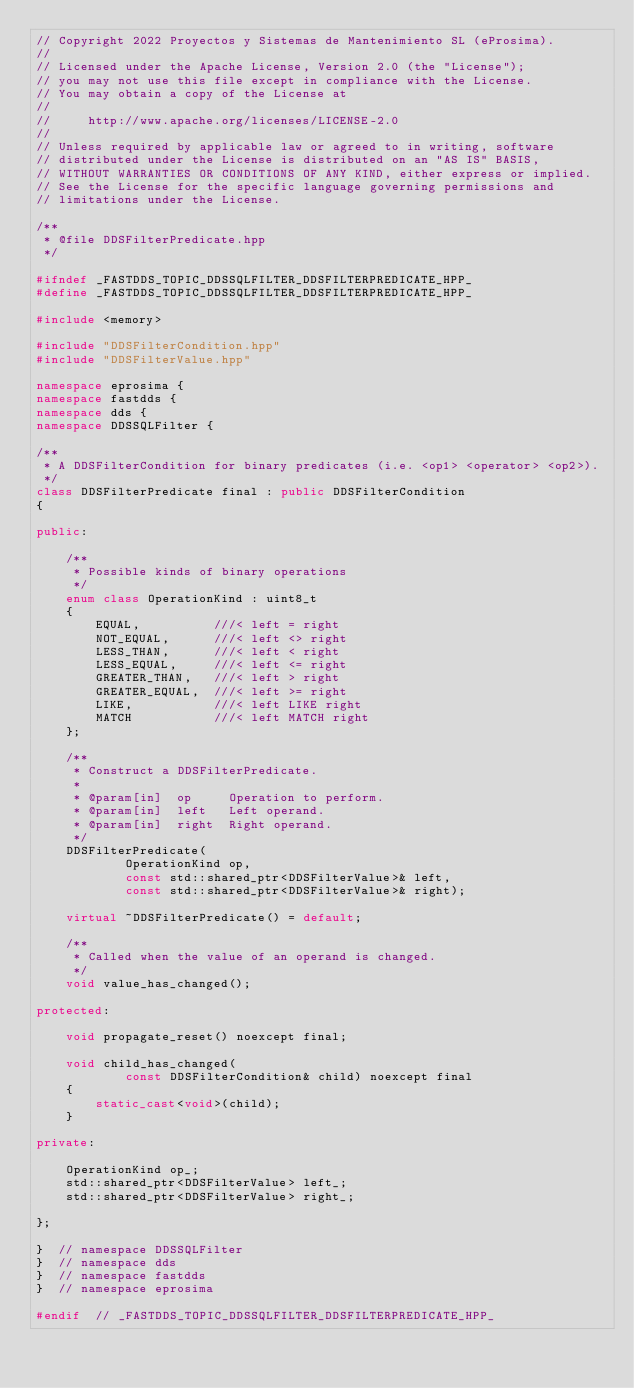Convert code to text. <code><loc_0><loc_0><loc_500><loc_500><_C++_>// Copyright 2022 Proyectos y Sistemas de Mantenimiento SL (eProsima).
//
// Licensed under the Apache License, Version 2.0 (the "License");
// you may not use this file except in compliance with the License.
// You may obtain a copy of the License at
//
//     http://www.apache.org/licenses/LICENSE-2.0
//
// Unless required by applicable law or agreed to in writing, software
// distributed under the License is distributed on an "AS IS" BASIS,
// WITHOUT WARRANTIES OR CONDITIONS OF ANY KIND, either express or implied.
// See the License for the specific language governing permissions and
// limitations under the License.

/**
 * @file DDSFilterPredicate.hpp
 */

#ifndef _FASTDDS_TOPIC_DDSSQLFILTER_DDSFILTERPREDICATE_HPP_
#define _FASTDDS_TOPIC_DDSSQLFILTER_DDSFILTERPREDICATE_HPP_

#include <memory>

#include "DDSFilterCondition.hpp"
#include "DDSFilterValue.hpp"

namespace eprosima {
namespace fastdds {
namespace dds {
namespace DDSSQLFilter {

/**
 * A DDSFilterCondition for binary predicates (i.e. <op1> <operator> <op2>).
 */
class DDSFilterPredicate final : public DDSFilterCondition
{

public:

    /**
     * Possible kinds of binary operations
     */
    enum class OperationKind : uint8_t
    {
        EQUAL,          ///< left = right
        NOT_EQUAL,      ///< left <> right
        LESS_THAN,      ///< left < right
        LESS_EQUAL,     ///< left <= right
        GREATER_THAN,   ///< left > right
        GREATER_EQUAL,  ///< left >= right
        LIKE,           ///< left LIKE right
        MATCH           ///< left MATCH right
    };

    /**
     * Construct a DDSFilterPredicate.
     *
     * @param[in]  op     Operation to perform.
     * @param[in]  left   Left operand.
     * @param[in]  right  Right operand.
     */
    DDSFilterPredicate(
            OperationKind op,
            const std::shared_ptr<DDSFilterValue>& left,
            const std::shared_ptr<DDSFilterValue>& right);

    virtual ~DDSFilterPredicate() = default;

    /**
     * Called when the value of an operand is changed.
     */
    void value_has_changed();

protected:

    void propagate_reset() noexcept final;

    void child_has_changed(
            const DDSFilterCondition& child) noexcept final
    {
        static_cast<void>(child);
    }

private:

    OperationKind op_;
    std::shared_ptr<DDSFilterValue> left_;
    std::shared_ptr<DDSFilterValue> right_;

};

}  // namespace DDSSQLFilter
}  // namespace dds
}  // namespace fastdds
}  // namespace eprosima

#endif  // _FASTDDS_TOPIC_DDSSQLFILTER_DDSFILTERPREDICATE_HPP_
</code> 